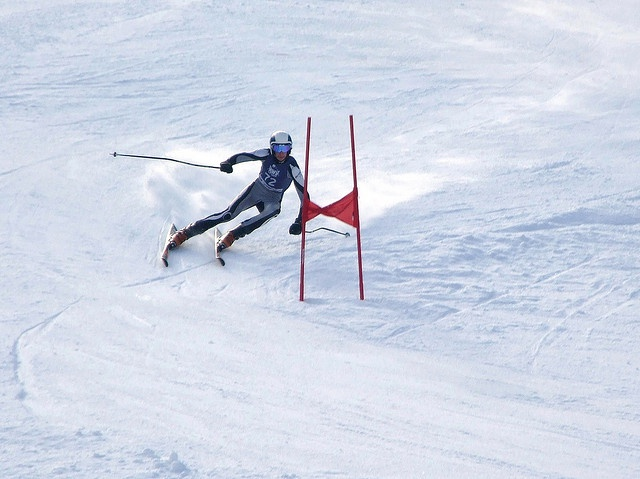Describe the objects in this image and their specific colors. I can see people in lavender, black, navy, gray, and darkblue tones and skis in lavender, darkgray, lightgray, and gray tones in this image. 